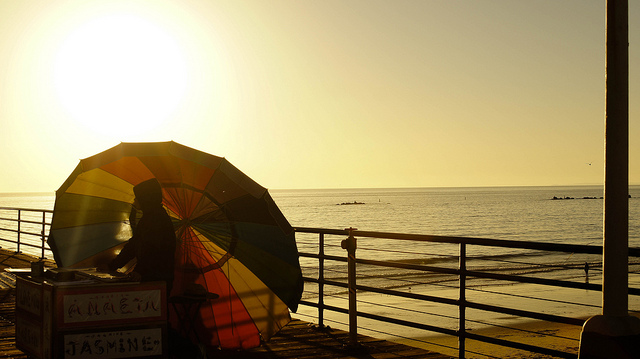How would you describe the scene captured in this image? The image captures a serene seaside scene during what appears to be sunset or sunrise, with a man standing behind a large, colorful beach umbrella. The golden hues of the sunlight enrich the calming blues of the sea, while the umbrella adds a vibrant contrast to the composition. It evokes a sense of peacefulness and the simple pleasure of being by the water at the end of a day. 